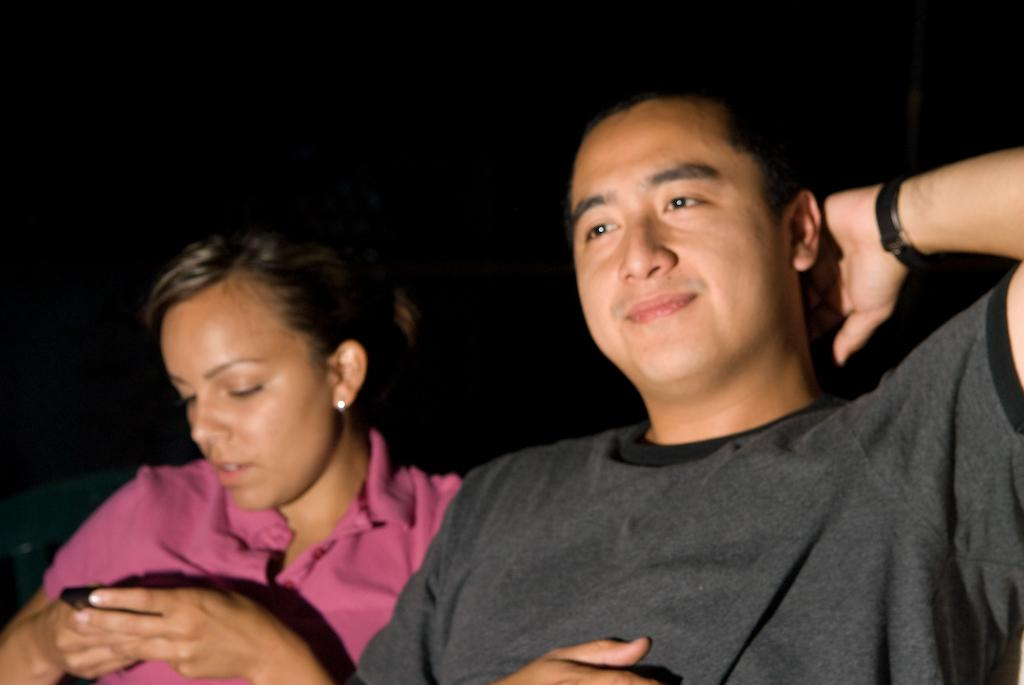How many people are present in the image? There are two people in the image, a man and a woman. What are the man and the woman wearing? Both the man and the woman are wearing t-shirts. What type of offer is the man making to the woman in the image? There is no indication in the image of any offer being made between the man and the woman. 